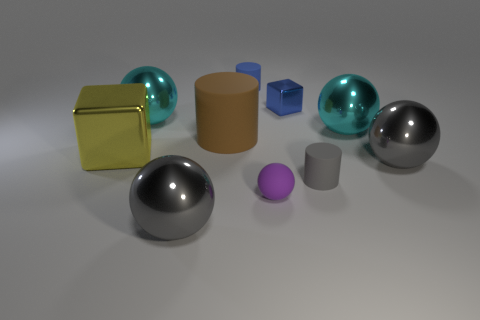Subtract 1 balls. How many balls are left? 4 Subtract all purple spheres. How many spheres are left? 4 Subtract all small matte spheres. How many spheres are left? 4 Subtract all blue spheres. Subtract all cyan cylinders. How many spheres are left? 5 Subtract all cylinders. How many objects are left? 7 Add 4 big metal things. How many big metal things exist? 9 Subtract 0 yellow balls. How many objects are left? 10 Subtract all blue cubes. Subtract all tiny blue cubes. How many objects are left? 8 Add 7 large cyan shiny things. How many large cyan shiny things are left? 9 